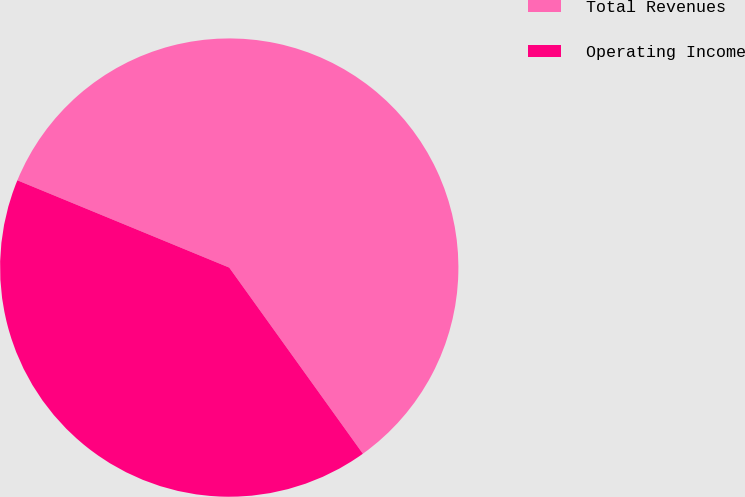Convert chart to OTSL. <chart><loc_0><loc_0><loc_500><loc_500><pie_chart><fcel>Total Revenues<fcel>Operating Income<nl><fcel>58.87%<fcel>41.13%<nl></chart> 